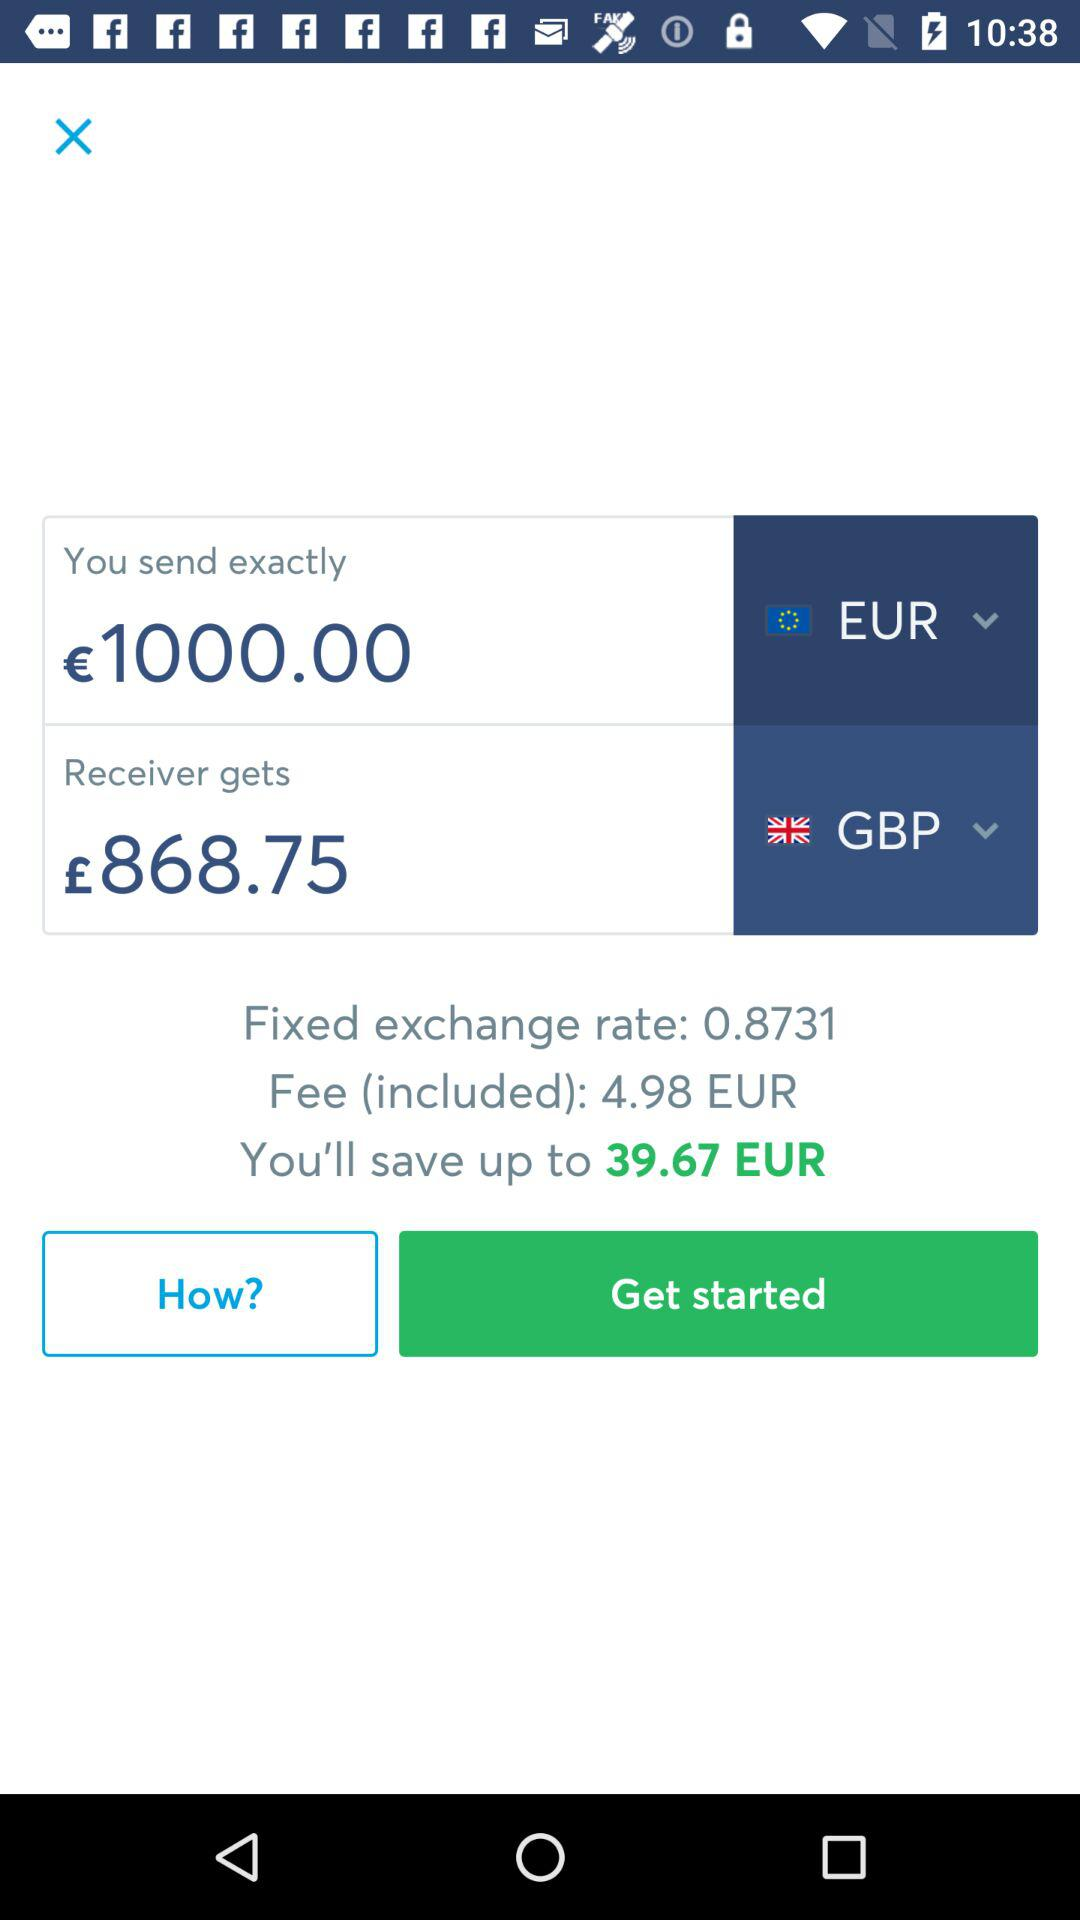What is the fixed exchange rate? The fixed exchange rate is 0.8731. 